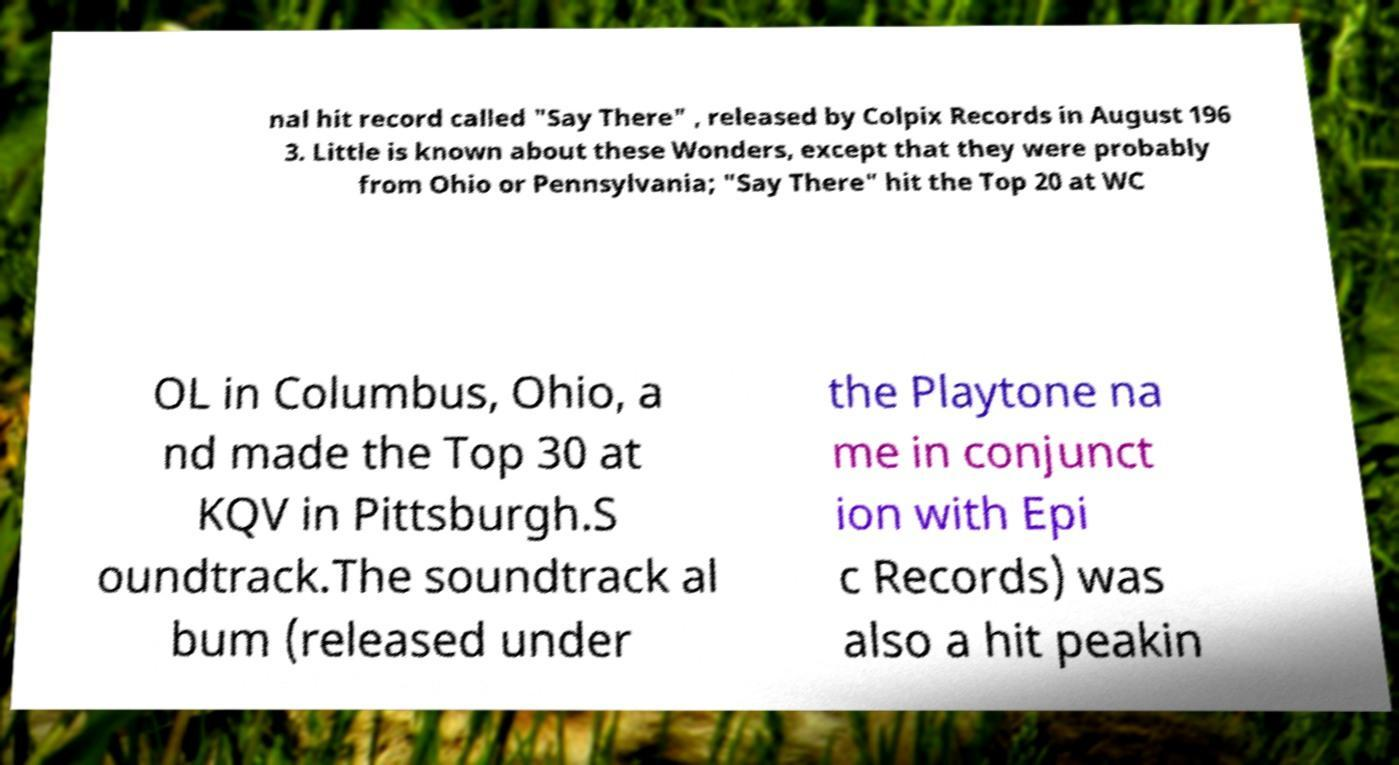I need the written content from this picture converted into text. Can you do that? nal hit record called "Say There" , released by Colpix Records in August 196 3. Little is known about these Wonders, except that they were probably from Ohio or Pennsylvania; "Say There" hit the Top 20 at WC OL in Columbus, Ohio, a nd made the Top 30 at KQV in Pittsburgh.S oundtrack.The soundtrack al bum (released under the Playtone na me in conjunct ion with Epi c Records) was also a hit peakin 